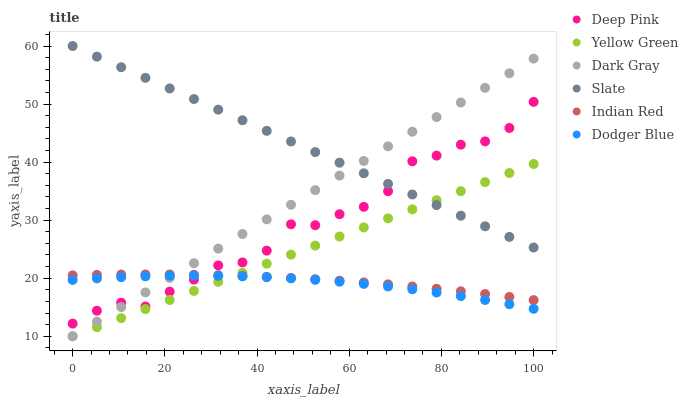Does Dodger Blue have the minimum area under the curve?
Answer yes or no. Yes. Does Slate have the maximum area under the curve?
Answer yes or no. Yes. Does Yellow Green have the minimum area under the curve?
Answer yes or no. No. Does Yellow Green have the maximum area under the curve?
Answer yes or no. No. Is Yellow Green the smoothest?
Answer yes or no. Yes. Is Deep Pink the roughest?
Answer yes or no. Yes. Is Slate the smoothest?
Answer yes or no. No. Is Slate the roughest?
Answer yes or no. No. Does Yellow Green have the lowest value?
Answer yes or no. Yes. Does Slate have the lowest value?
Answer yes or no. No. Does Slate have the highest value?
Answer yes or no. Yes. Does Yellow Green have the highest value?
Answer yes or no. No. Is Yellow Green less than Deep Pink?
Answer yes or no. Yes. Is Slate greater than Dodger Blue?
Answer yes or no. Yes. Does Yellow Green intersect Dodger Blue?
Answer yes or no. Yes. Is Yellow Green less than Dodger Blue?
Answer yes or no. No. Is Yellow Green greater than Dodger Blue?
Answer yes or no. No. Does Yellow Green intersect Deep Pink?
Answer yes or no. No. 